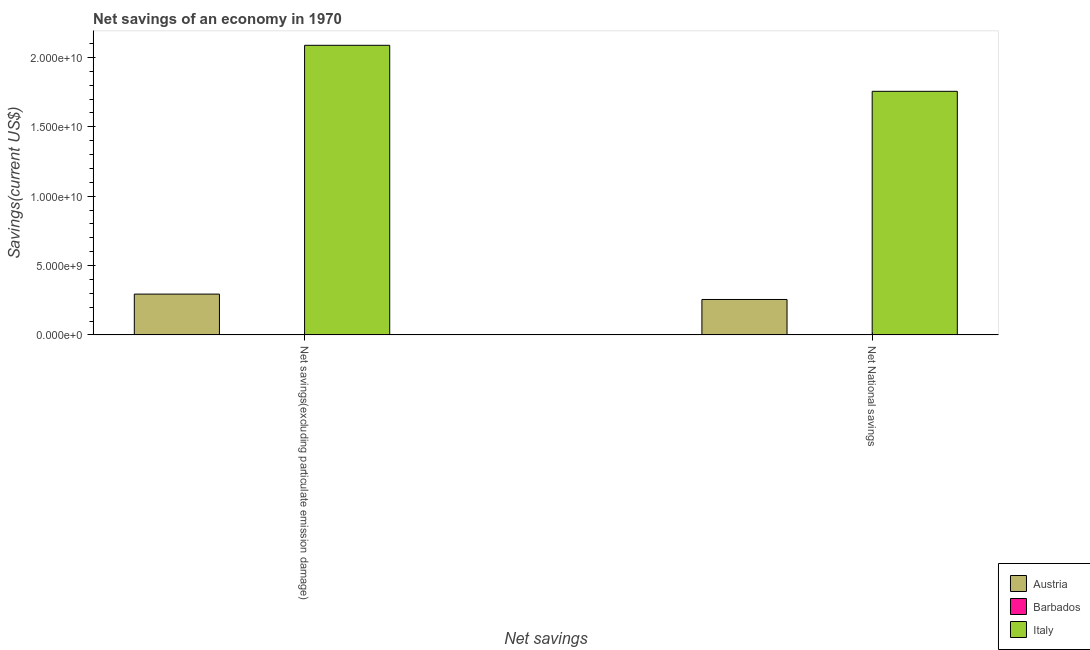How many different coloured bars are there?
Your response must be concise. 3. How many groups of bars are there?
Keep it short and to the point. 2. Are the number of bars per tick equal to the number of legend labels?
Make the answer very short. Yes. What is the label of the 1st group of bars from the left?
Offer a very short reply. Net savings(excluding particulate emission damage). What is the net national savings in Barbados?
Offer a terse response. 1.34e+07. Across all countries, what is the maximum net savings(excluding particulate emission damage)?
Keep it short and to the point. 2.09e+1. Across all countries, what is the minimum net savings(excluding particulate emission damage)?
Your answer should be very brief. 2.23e+07. In which country was the net savings(excluding particulate emission damage) minimum?
Your answer should be compact. Barbados. What is the total net national savings in the graph?
Offer a very short reply. 2.01e+1. What is the difference between the net national savings in Barbados and that in Italy?
Offer a terse response. -1.75e+1. What is the difference between the net national savings in Italy and the net savings(excluding particulate emission damage) in Austria?
Provide a succinct answer. 1.46e+1. What is the average net savings(excluding particulate emission damage) per country?
Offer a very short reply. 7.94e+09. What is the difference between the net savings(excluding particulate emission damage) and net national savings in Barbados?
Offer a terse response. 8.97e+06. What is the ratio of the net national savings in Italy to that in Austria?
Your response must be concise. 6.88. Is the net savings(excluding particulate emission damage) in Italy less than that in Austria?
Ensure brevity in your answer.  No. In how many countries, is the net savings(excluding particulate emission damage) greater than the average net savings(excluding particulate emission damage) taken over all countries?
Make the answer very short. 1. What does the 2nd bar from the left in Net National savings represents?
Provide a short and direct response. Barbados. What does the 1st bar from the right in Net National savings represents?
Your answer should be very brief. Italy. Are all the bars in the graph horizontal?
Give a very brief answer. No. How many countries are there in the graph?
Your answer should be compact. 3. Does the graph contain any zero values?
Ensure brevity in your answer.  No. How many legend labels are there?
Ensure brevity in your answer.  3. What is the title of the graph?
Ensure brevity in your answer.  Net savings of an economy in 1970. Does "Northern Mariana Islands" appear as one of the legend labels in the graph?
Your answer should be compact. No. What is the label or title of the X-axis?
Offer a very short reply. Net savings. What is the label or title of the Y-axis?
Your response must be concise. Savings(current US$). What is the Savings(current US$) of Austria in Net savings(excluding particulate emission damage)?
Your response must be concise. 2.94e+09. What is the Savings(current US$) of Barbados in Net savings(excluding particulate emission damage)?
Ensure brevity in your answer.  2.23e+07. What is the Savings(current US$) in Italy in Net savings(excluding particulate emission damage)?
Keep it short and to the point. 2.09e+1. What is the Savings(current US$) of Austria in Net National savings?
Provide a succinct answer. 2.55e+09. What is the Savings(current US$) of Barbados in Net National savings?
Make the answer very short. 1.34e+07. What is the Savings(current US$) of Italy in Net National savings?
Ensure brevity in your answer.  1.76e+1. Across all Net savings, what is the maximum Savings(current US$) in Austria?
Offer a terse response. 2.94e+09. Across all Net savings, what is the maximum Savings(current US$) of Barbados?
Provide a short and direct response. 2.23e+07. Across all Net savings, what is the maximum Savings(current US$) of Italy?
Offer a very short reply. 2.09e+1. Across all Net savings, what is the minimum Savings(current US$) of Austria?
Offer a very short reply. 2.55e+09. Across all Net savings, what is the minimum Savings(current US$) in Barbados?
Offer a terse response. 1.34e+07. Across all Net savings, what is the minimum Savings(current US$) in Italy?
Provide a short and direct response. 1.76e+1. What is the total Savings(current US$) in Austria in the graph?
Ensure brevity in your answer.  5.49e+09. What is the total Savings(current US$) in Barbados in the graph?
Your response must be concise. 3.57e+07. What is the total Savings(current US$) in Italy in the graph?
Your answer should be very brief. 3.84e+1. What is the difference between the Savings(current US$) in Austria in Net savings(excluding particulate emission damage) and that in Net National savings?
Provide a succinct answer. 3.88e+08. What is the difference between the Savings(current US$) of Barbados in Net savings(excluding particulate emission damage) and that in Net National savings?
Offer a terse response. 8.97e+06. What is the difference between the Savings(current US$) in Italy in Net savings(excluding particulate emission damage) and that in Net National savings?
Provide a succinct answer. 3.32e+09. What is the difference between the Savings(current US$) in Austria in Net savings(excluding particulate emission damage) and the Savings(current US$) in Barbados in Net National savings?
Ensure brevity in your answer.  2.93e+09. What is the difference between the Savings(current US$) in Austria in Net savings(excluding particulate emission damage) and the Savings(current US$) in Italy in Net National savings?
Offer a very short reply. -1.46e+1. What is the difference between the Savings(current US$) of Barbados in Net savings(excluding particulate emission damage) and the Savings(current US$) of Italy in Net National savings?
Provide a short and direct response. -1.75e+1. What is the average Savings(current US$) in Austria per Net savings?
Offer a terse response. 2.75e+09. What is the average Savings(current US$) in Barbados per Net savings?
Keep it short and to the point. 1.78e+07. What is the average Savings(current US$) of Italy per Net savings?
Keep it short and to the point. 1.92e+1. What is the difference between the Savings(current US$) in Austria and Savings(current US$) in Barbados in Net savings(excluding particulate emission damage)?
Give a very brief answer. 2.92e+09. What is the difference between the Savings(current US$) in Austria and Savings(current US$) in Italy in Net savings(excluding particulate emission damage)?
Provide a succinct answer. -1.79e+1. What is the difference between the Savings(current US$) in Barbados and Savings(current US$) in Italy in Net savings(excluding particulate emission damage)?
Provide a short and direct response. -2.08e+1. What is the difference between the Savings(current US$) of Austria and Savings(current US$) of Barbados in Net National savings?
Your answer should be compact. 2.54e+09. What is the difference between the Savings(current US$) in Austria and Savings(current US$) in Italy in Net National savings?
Your answer should be compact. -1.50e+1. What is the difference between the Savings(current US$) in Barbados and Savings(current US$) in Italy in Net National savings?
Keep it short and to the point. -1.75e+1. What is the ratio of the Savings(current US$) in Austria in Net savings(excluding particulate emission damage) to that in Net National savings?
Your answer should be compact. 1.15. What is the ratio of the Savings(current US$) of Barbados in Net savings(excluding particulate emission damage) to that in Net National savings?
Provide a short and direct response. 1.67. What is the ratio of the Savings(current US$) of Italy in Net savings(excluding particulate emission damage) to that in Net National savings?
Offer a terse response. 1.19. What is the difference between the highest and the second highest Savings(current US$) of Austria?
Ensure brevity in your answer.  3.88e+08. What is the difference between the highest and the second highest Savings(current US$) in Barbados?
Offer a very short reply. 8.97e+06. What is the difference between the highest and the second highest Savings(current US$) in Italy?
Give a very brief answer. 3.32e+09. What is the difference between the highest and the lowest Savings(current US$) in Austria?
Provide a succinct answer. 3.88e+08. What is the difference between the highest and the lowest Savings(current US$) of Barbados?
Ensure brevity in your answer.  8.97e+06. What is the difference between the highest and the lowest Savings(current US$) of Italy?
Provide a succinct answer. 3.32e+09. 